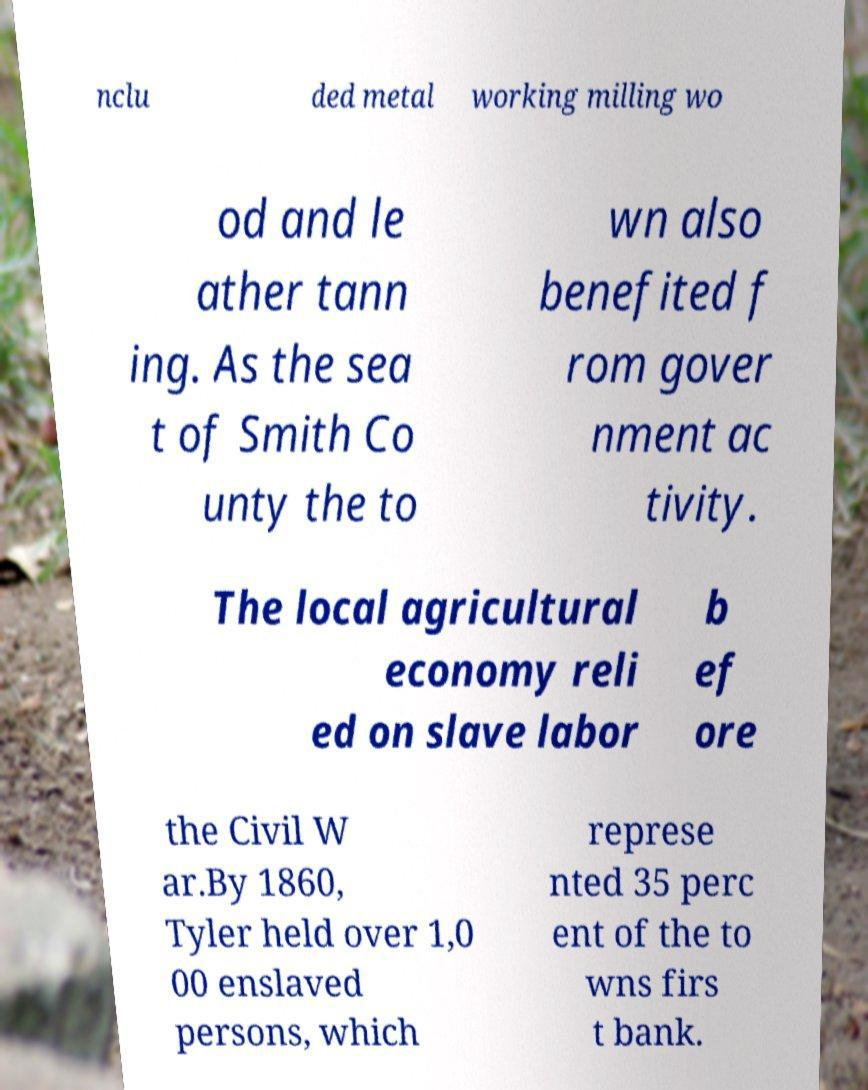For documentation purposes, I need the text within this image transcribed. Could you provide that? nclu ded metal working milling wo od and le ather tann ing. As the sea t of Smith Co unty the to wn also benefited f rom gover nment ac tivity. The local agricultural economy reli ed on slave labor b ef ore the Civil W ar.By 1860, Tyler held over 1,0 00 enslaved persons, which represe nted 35 perc ent of the to wns firs t bank. 